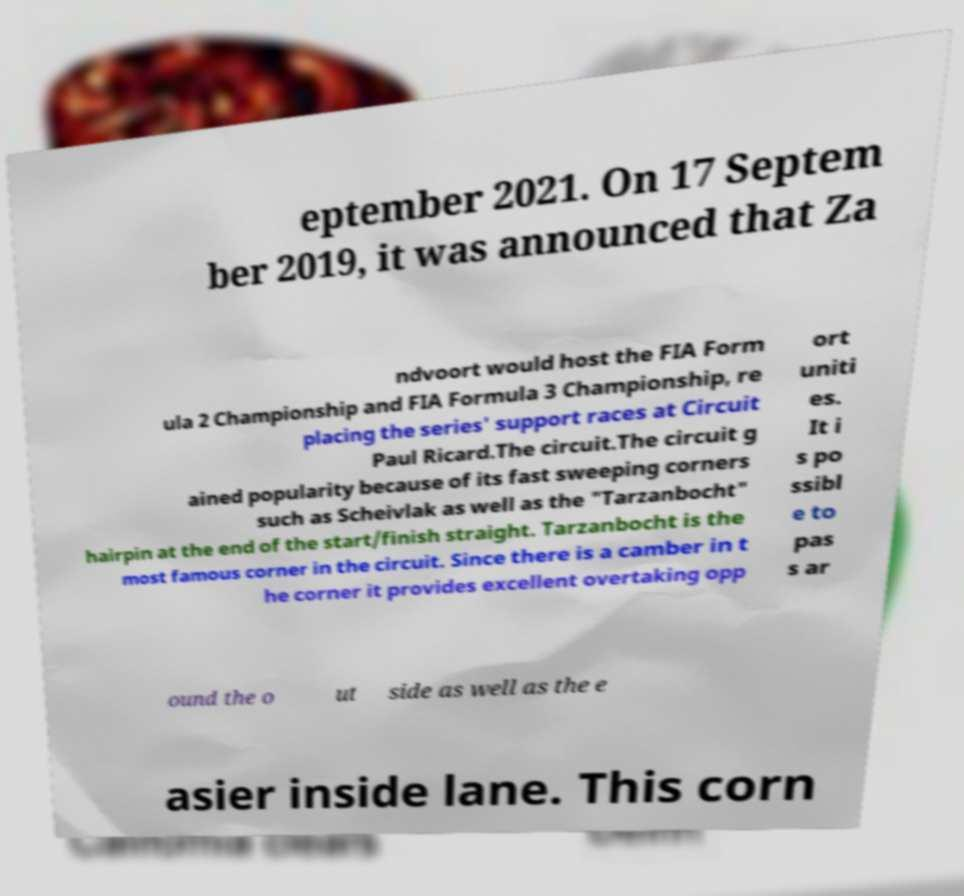Can you read and provide the text displayed in the image?This photo seems to have some interesting text. Can you extract and type it out for me? eptember 2021. On 17 Septem ber 2019, it was announced that Za ndvoort would host the FIA Form ula 2 Championship and FIA Formula 3 Championship, re placing the series' support races at Circuit Paul Ricard.The circuit.The circuit g ained popularity because of its fast sweeping corners such as Scheivlak as well as the "Tarzanbocht" hairpin at the end of the start/finish straight. Tarzanbocht is the most famous corner in the circuit. Since there is a camber in t he corner it provides excellent overtaking opp ort uniti es. It i s po ssibl e to pas s ar ound the o ut side as well as the e asier inside lane. This corn 